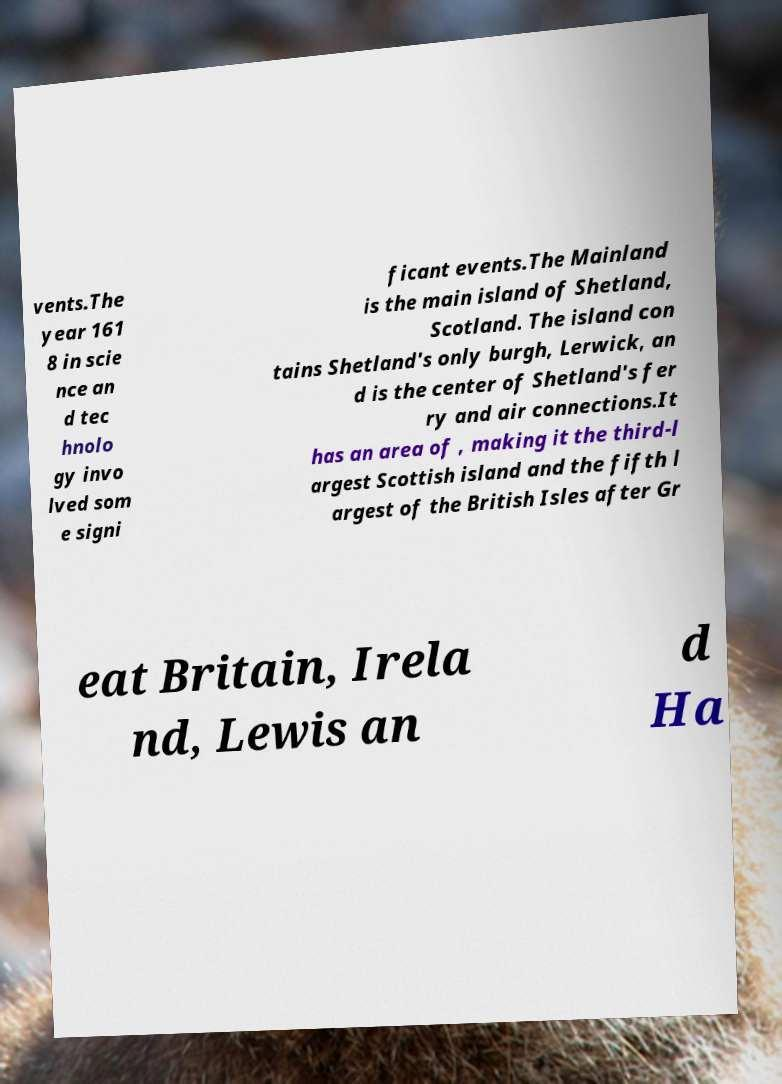What messages or text are displayed in this image? I need them in a readable, typed format. vents.The year 161 8 in scie nce an d tec hnolo gy invo lved som e signi ficant events.The Mainland is the main island of Shetland, Scotland. The island con tains Shetland's only burgh, Lerwick, an d is the center of Shetland's fer ry and air connections.It has an area of , making it the third-l argest Scottish island and the fifth l argest of the British Isles after Gr eat Britain, Irela nd, Lewis an d Ha 